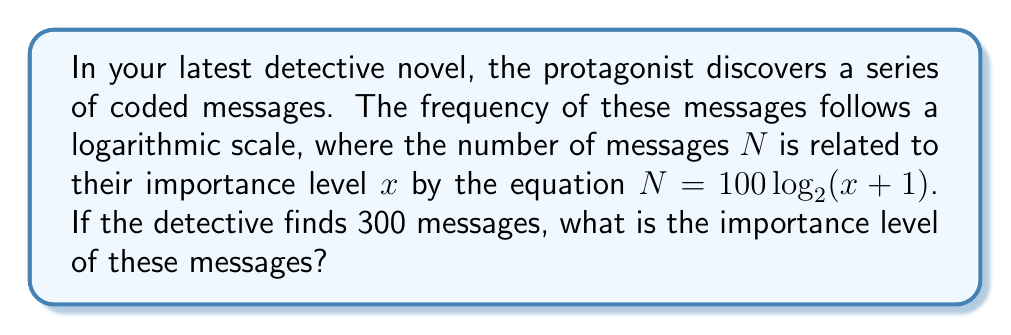Can you solve this math problem? Let's approach this step-by-step:

1) We're given the equation: $N = 100 \log_{2}(x+1)$
   Where $N$ is the number of messages and $x$ is the importance level.

2) We know that $N = 300$, so we can substitute this:
   $300 = 100 \log_{2}(x+1)$

3) Divide both sides by 100:
   $3 = \log_{2}(x+1)$

4) To solve for $x$, we need to apply the inverse function of $\log_2$, which is $2^y$:
   $2^3 = x+1$

5) Calculate $2^3$:
   $8 = x+1$

6) Subtract 1 from both sides:
   $7 = x$

Therefore, the importance level of the messages is 7.
Answer: 7 